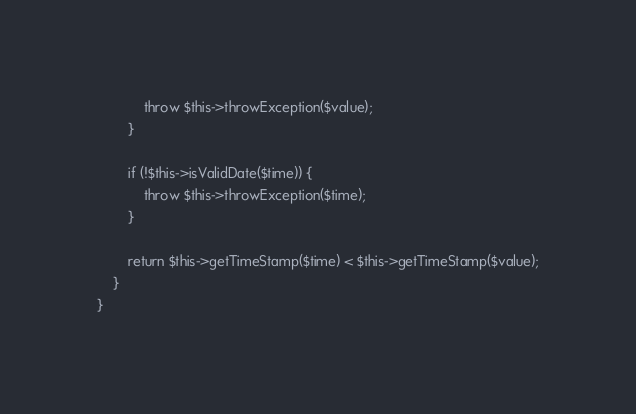<code> <loc_0><loc_0><loc_500><loc_500><_PHP_>            throw $this->throwException($value);
        }

        if (!$this->isValidDate($time)) {
            throw $this->throwException($time);
        }

        return $this->getTimeStamp($time) < $this->getTimeStamp($value);
    }
}
</code> 